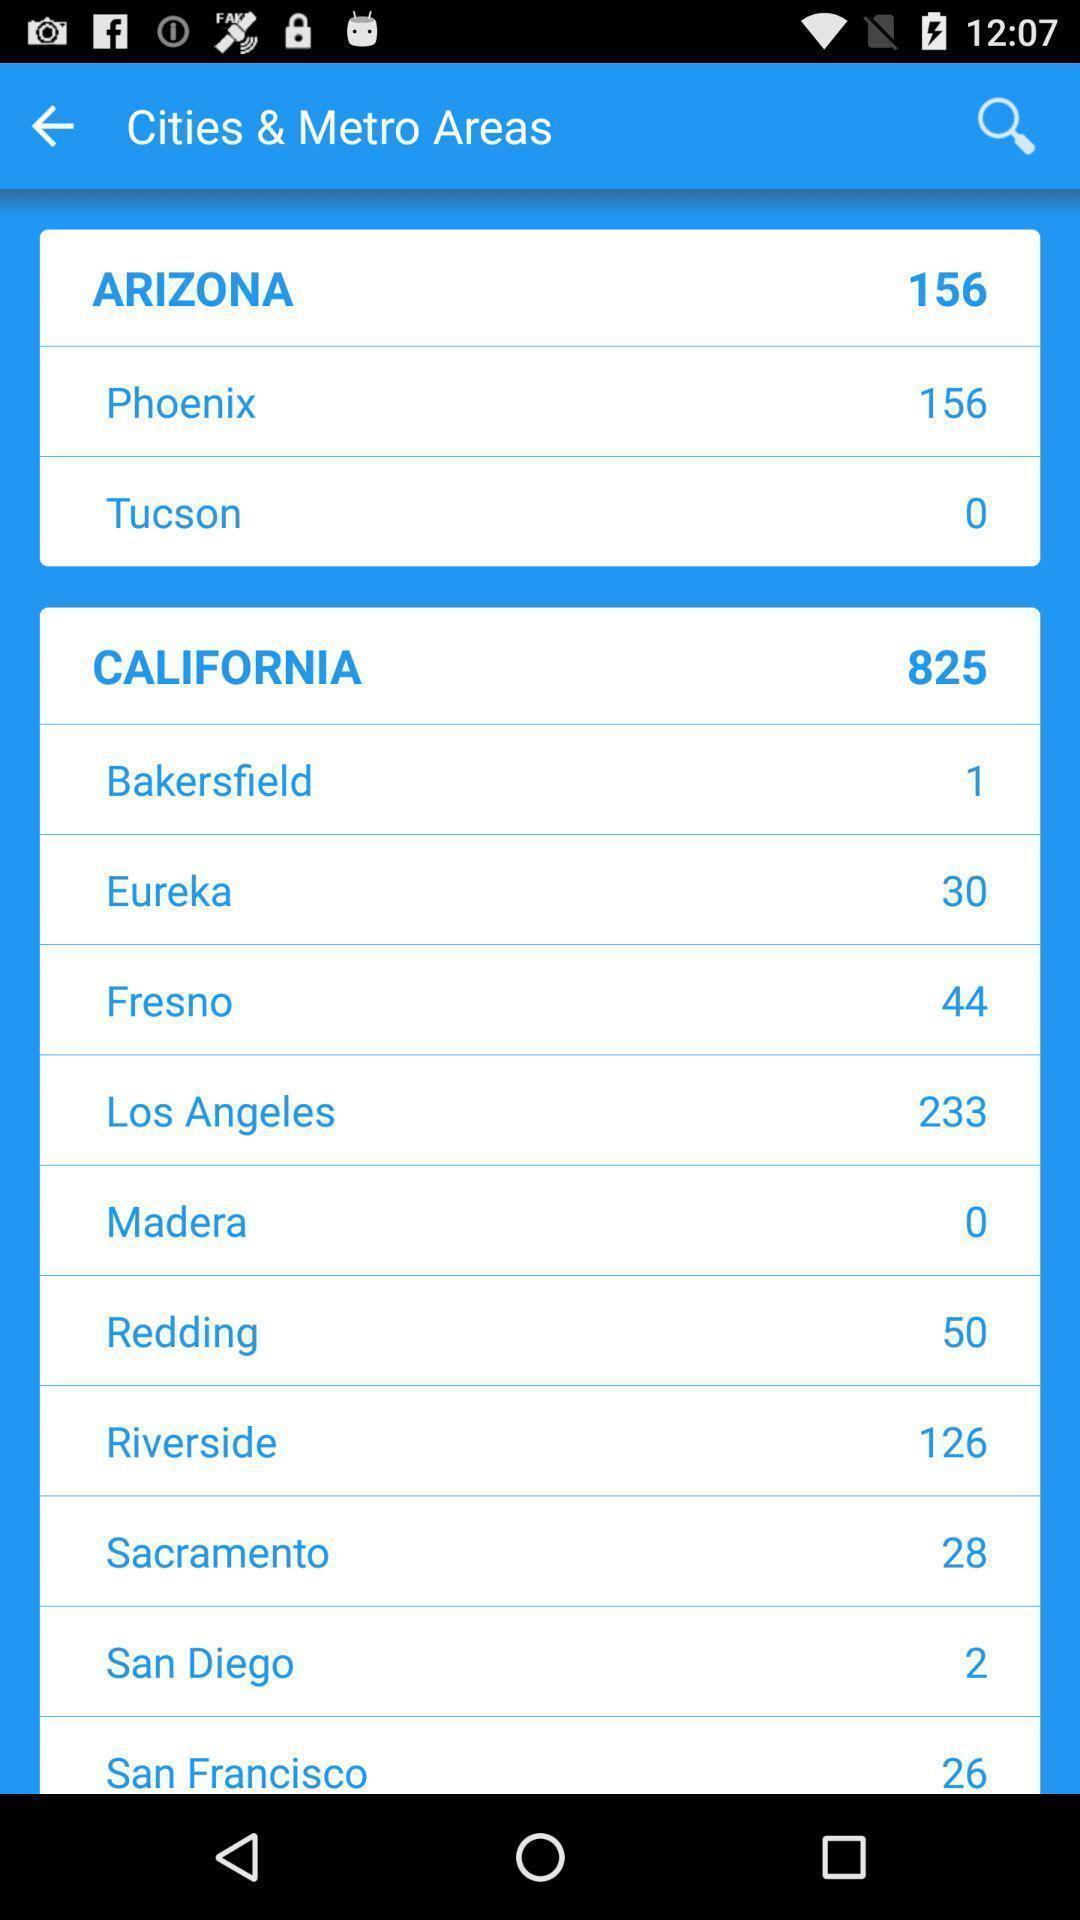Summarize the information in this screenshot. Screen showing list of various cities and metro areas. 